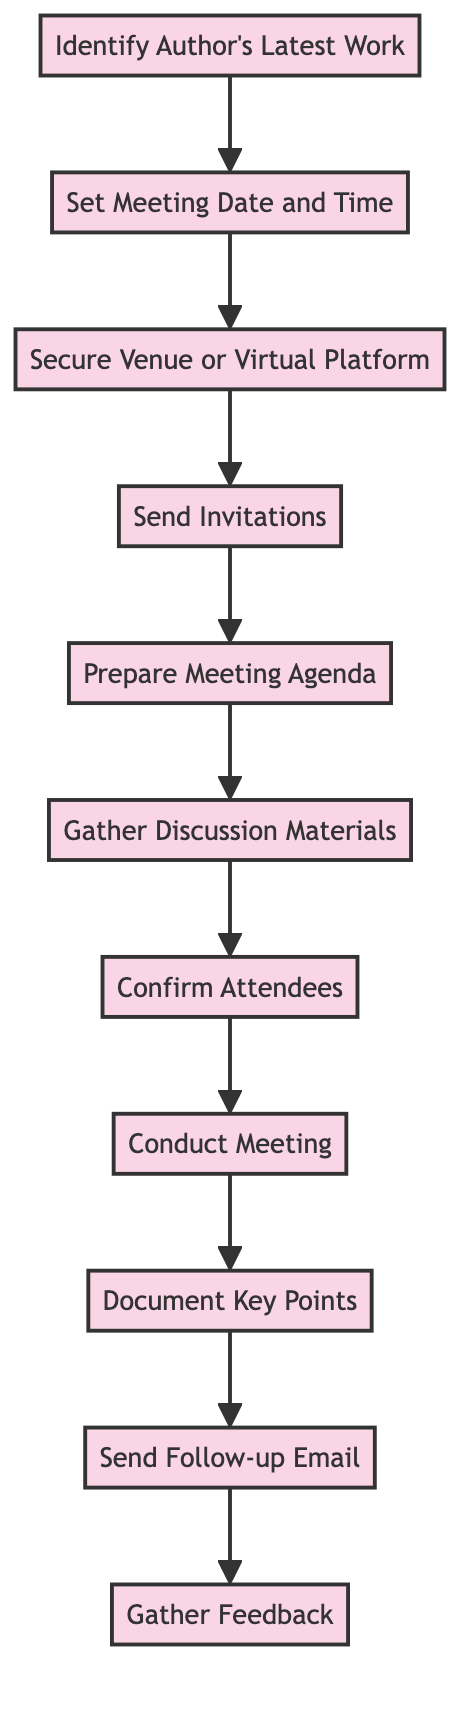What is the first step in the process? The first step is "Identify Author's Latest Work," which indicates that the process begins with reviewing the author's recent publications.
Answer: Identify Author's Latest Work How many nodes are there in the diagram? Counting all the distinct steps in the flowchart, there are a total of 11 nodes that represent different activities in the meeting organization process.
Answer: 11 What action follows 'Send Invitations'? After 'Send Invitations,' the next action is 'Prepare Meeting Agenda.' This indicates that creating an agenda comes after distributing invitations to participants.
Answer: Prepare Meeting Agenda Which step comes last in the flow? The last step in the flow is 'Gather Feedback,' which indicates that this task is performed after all prior actions have been completed and discussed.
Answer: Gather Feedback How many edges connect the nodes in the diagram? Each node connects to the next one with a directed edge, so counting these connections between all 11 nodes gives a total of 10 edges in the flowchart.
Answer: 10 What is the relationship between 'Conduct Meeting' and 'Document Key Points'? The relationship is sequential; 'Conduct Meeting' leads to 'Document Key Points,' meaning that after the meeting takes place, the key points discussed are documented.
Answer: Sequential Which action must be taken before 'Gather Discussion Materials'? Before 'Gather Discussion Materials,' the action 'Prepare Meeting Agenda' must be completed, as it is necessary to know the agenda before collecting related materials.
Answer: Prepare Meeting Agenda What is the purpose of the 'Send Follow-up Email'? The purpose of the 'Send Follow-up Email' is to summarize the meeting, including key discussion points and future action items, which serves to keep participants informed.
Answer: Summarize meeting Which step requires confirming participants' presence? The step that requires confirming participants' presence is 'Confirm Attendees,' as it is specifically focused on checking who will attend the meeting.
Answer: Confirm Attendees 